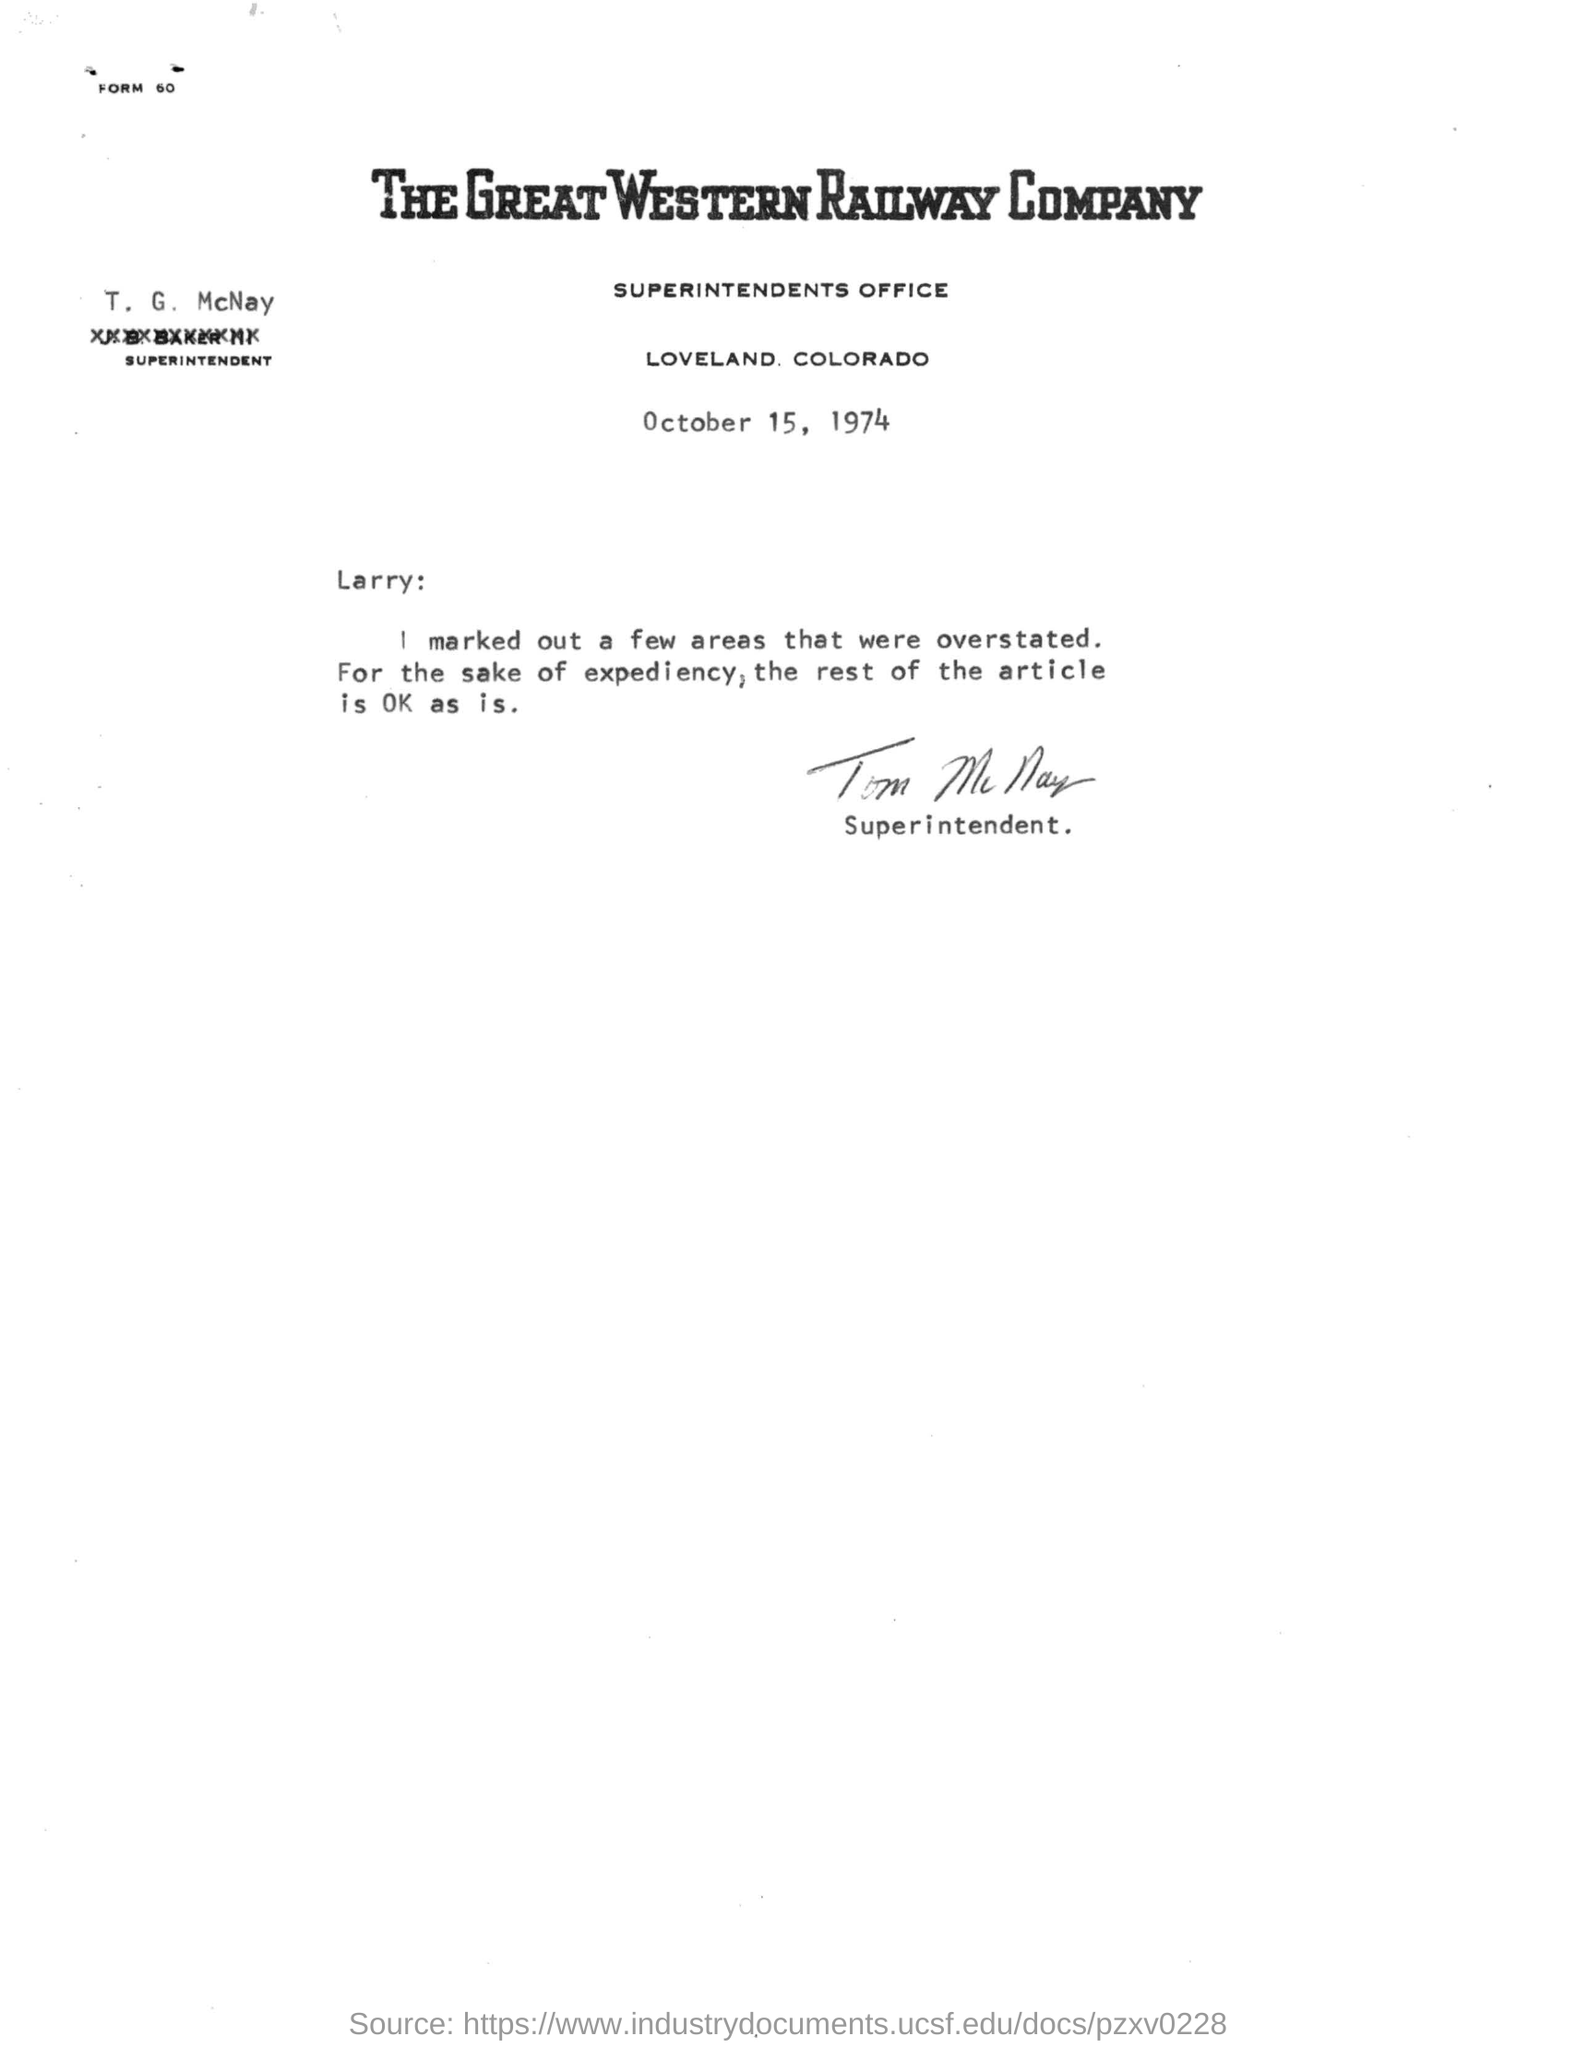What is the date of the letter?
Ensure brevity in your answer.  OCTOBER 15, 1974. Who is the superintendent?
Your answer should be compact. T.G. MCNAY. To whom the letter is addressed to?
Provide a succinct answer. LARRY. 